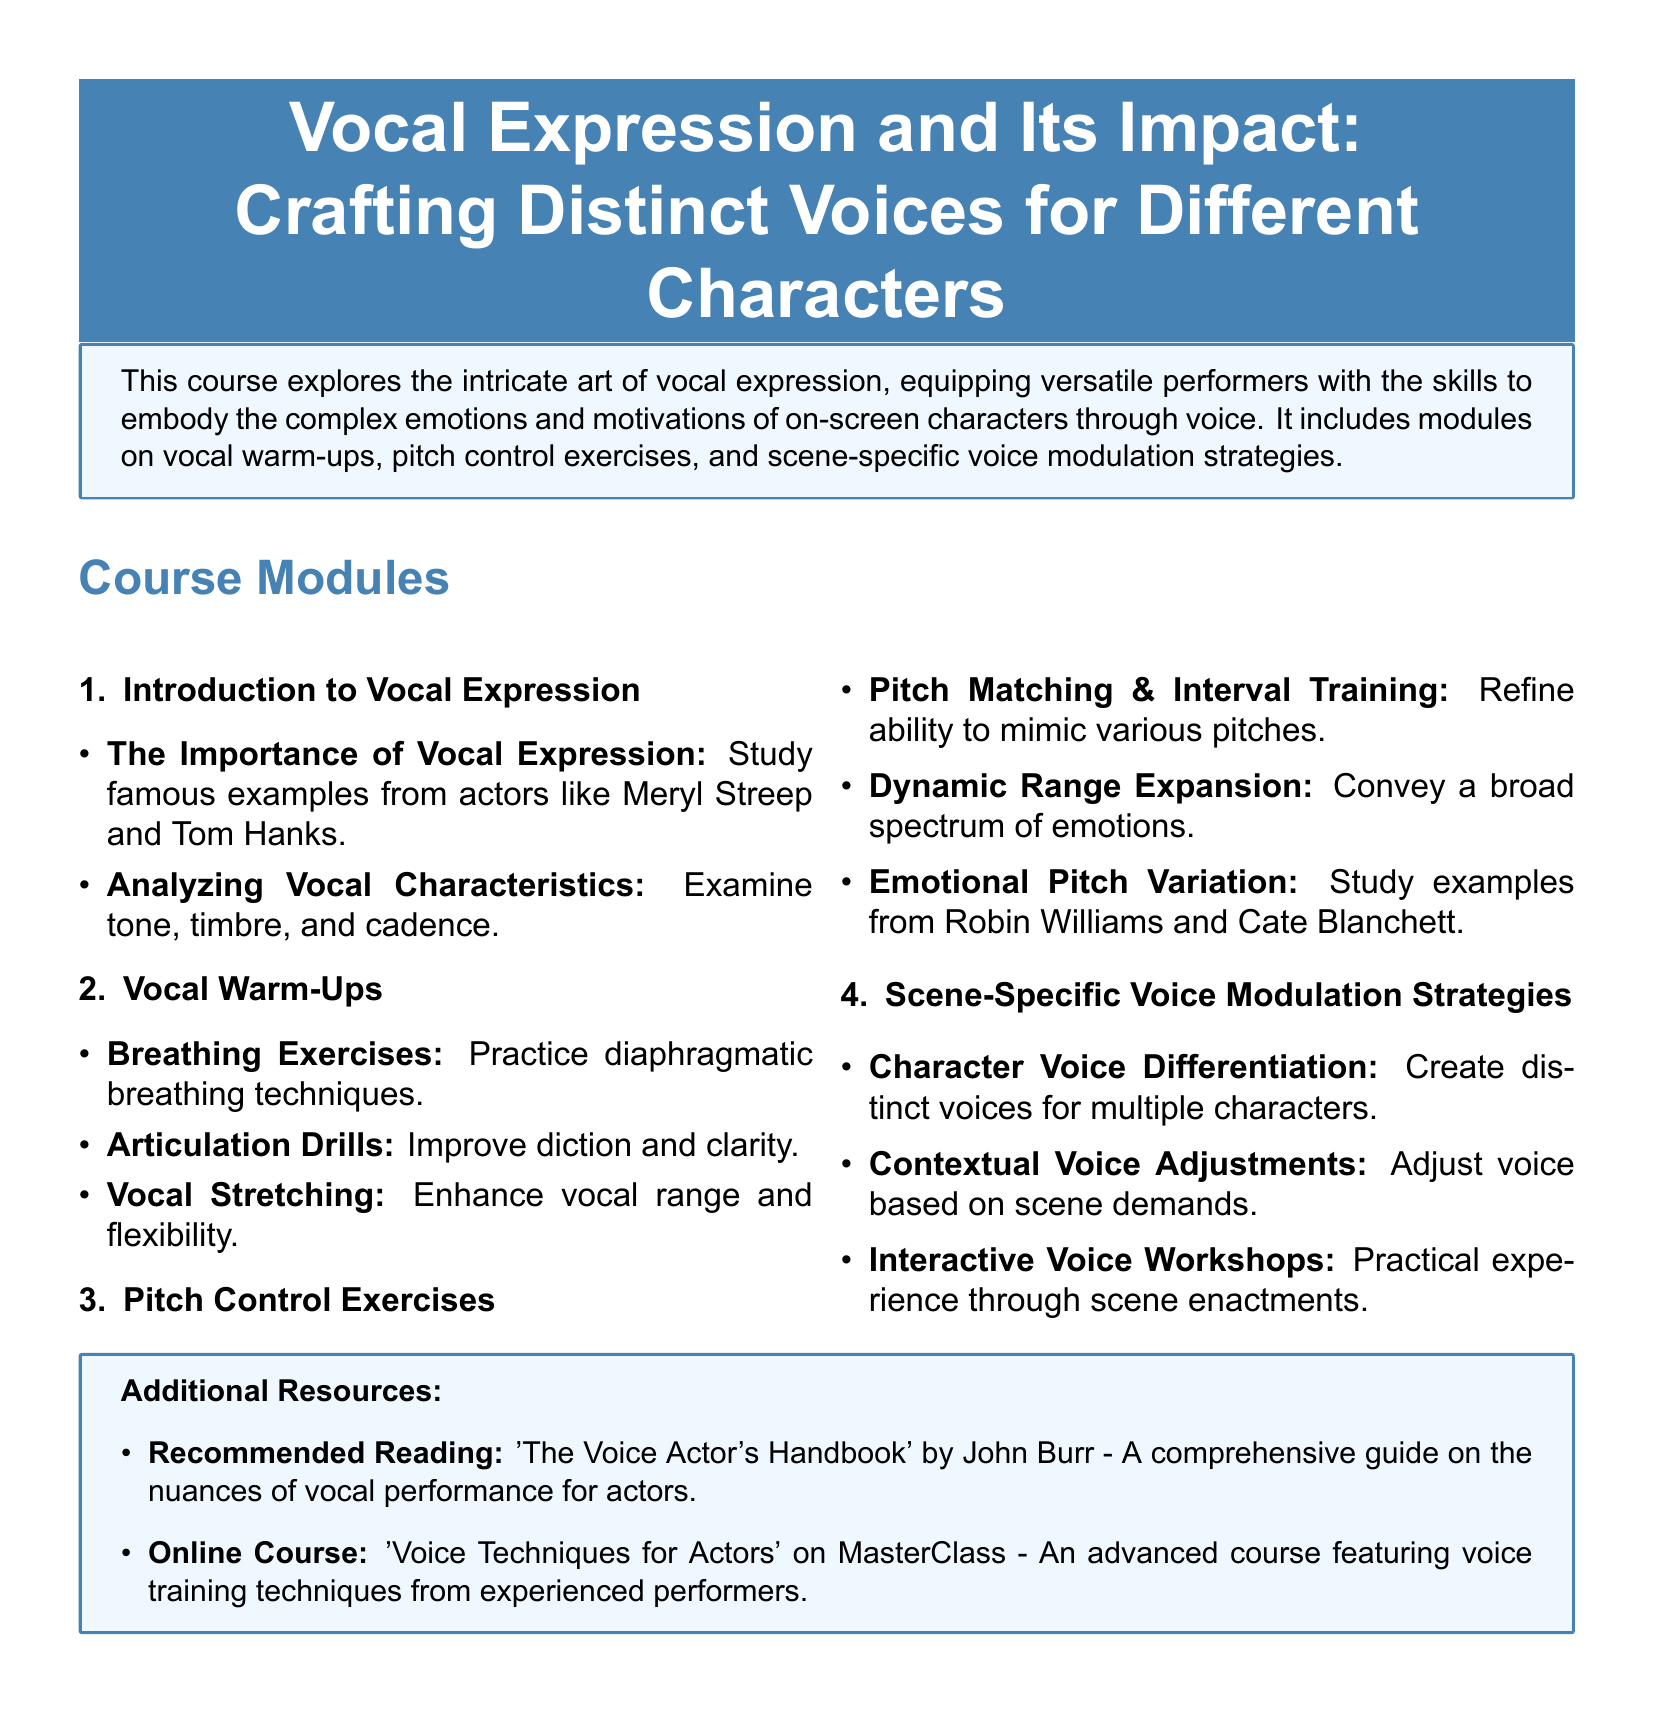What is the title of the course? The title of the course is stated at the beginning: 'Vocal Expression and Its Impact: Crafting Distinct Voices for Different Characters.'
Answer: Vocal Expression and Its Impact: Crafting Distinct Voices for Different Characters How many main modules are included in the syllabus? The total number of main modules listed is 4, including 'Introduction to Vocal Expression,' 'Vocal Warm-Ups,' 'Pitch Control Exercises,' and 'Scene-Specific Voice Modulation Strategies.'
Answer: 4 Who is the author of the recommended reading? The recommended reading is 'The Voice Actor's Handbook' by John Burr, which tells us the author of this book is John Burr.
Answer: John Burr What type of exercises are included in Vocal Warm-Ups? The Vocal Warm-Ups module includes breathing exercises, articulation drills, and vocal stretching, indicating these are essential warm-up activities.
Answer: Breathing exercises, articulation drills, vocal stretching What is emphasized in the Pitch Control Exercises module? The module emphasizes pitch matching, dynamic range expansion, and emotional pitch variation to develop pitch control in vocal performance.
Answer: Pitch matching, dynamic range expansion, emotional pitch variation What is a key learning activity in the Scene-Specific Voice Modulation Strategies module? A key learning activity in the module is 'Interactive Voice Workshops,' which involves practical experience through scene enactments.
Answer: Interactive Voice Workshops How does the course plan to help performers? The course aims to help versatile performers embody complex emotions and motivations of characters through their vocal expression.
Answer: Through vocal expression Which two actors are mentioned for emotional pitch variation? The syllabus references Robin Williams and Cate Blanchett as examples for studying emotional pitch variation.
Answer: Robin Williams and Cate Blanchett 